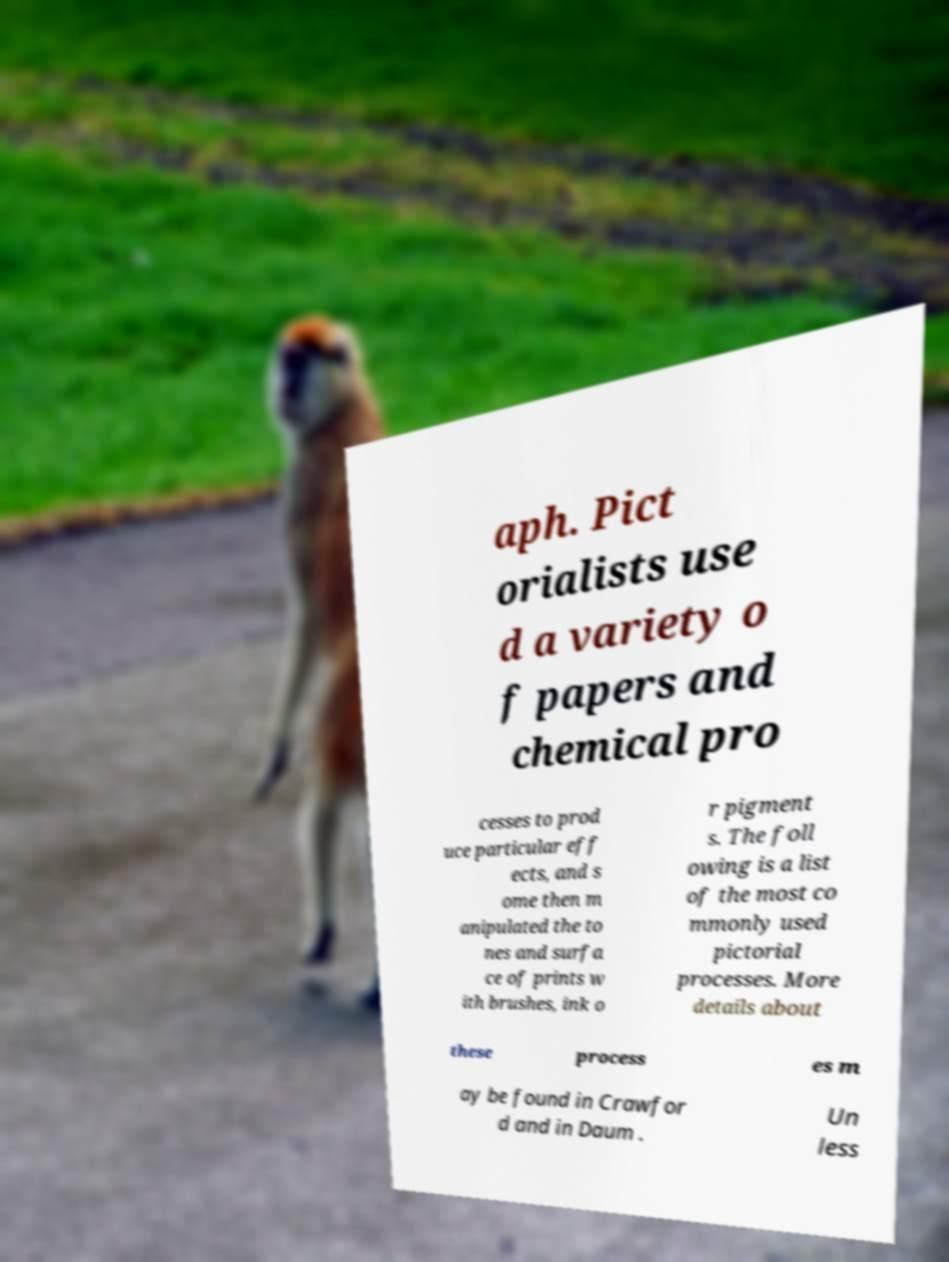Could you assist in decoding the text presented in this image and type it out clearly? aph. Pict orialists use d a variety o f papers and chemical pro cesses to prod uce particular eff ects, and s ome then m anipulated the to nes and surfa ce of prints w ith brushes, ink o r pigment s. The foll owing is a list of the most co mmonly used pictorial processes. More details about these process es m ay be found in Crawfor d and in Daum . Un less 